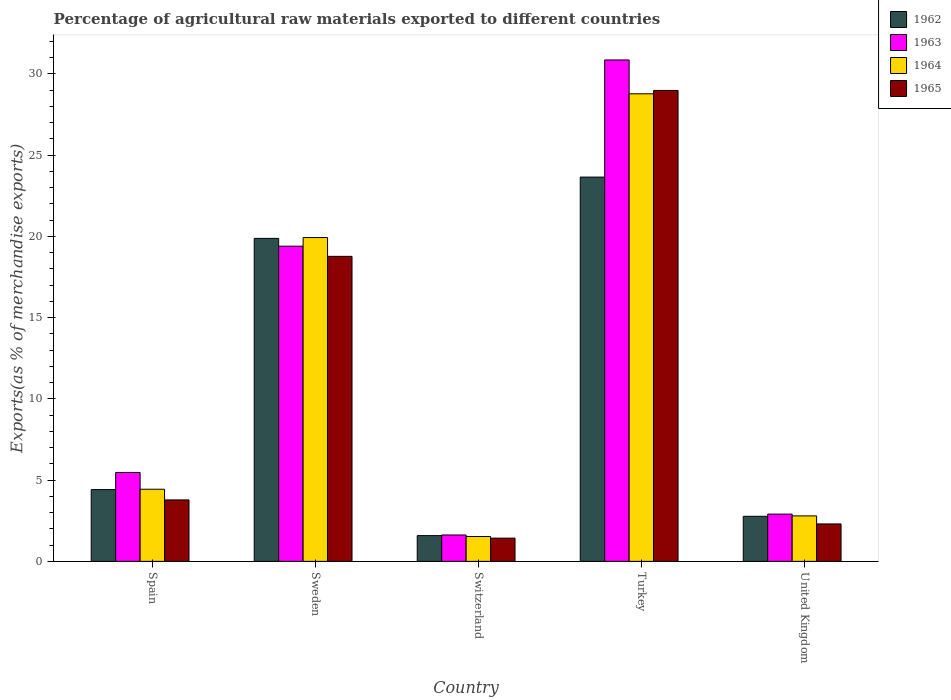How many different coloured bars are there?
Provide a short and direct response. 4. Are the number of bars per tick equal to the number of legend labels?
Provide a succinct answer. Yes. Are the number of bars on each tick of the X-axis equal?
Your answer should be very brief. Yes. How many bars are there on the 3rd tick from the left?
Your answer should be compact. 4. How many bars are there on the 1st tick from the right?
Your response must be concise. 4. In how many cases, is the number of bars for a given country not equal to the number of legend labels?
Your answer should be compact. 0. What is the percentage of exports to different countries in 1965 in United Kingdom?
Your response must be concise. 2.3. Across all countries, what is the maximum percentage of exports to different countries in 1965?
Ensure brevity in your answer.  28.99. Across all countries, what is the minimum percentage of exports to different countries in 1962?
Provide a succinct answer. 1.58. In which country was the percentage of exports to different countries in 1962 maximum?
Provide a short and direct response. Turkey. In which country was the percentage of exports to different countries in 1962 minimum?
Your answer should be very brief. Switzerland. What is the total percentage of exports to different countries in 1963 in the graph?
Provide a short and direct response. 60.27. What is the difference between the percentage of exports to different countries in 1964 in Sweden and that in Turkey?
Your answer should be very brief. -8.85. What is the difference between the percentage of exports to different countries in 1963 in Sweden and the percentage of exports to different countries in 1964 in Turkey?
Offer a very short reply. -9.38. What is the average percentage of exports to different countries in 1965 per country?
Give a very brief answer. 11.06. What is the difference between the percentage of exports to different countries of/in 1964 and percentage of exports to different countries of/in 1963 in Turkey?
Offer a terse response. -2.08. In how many countries, is the percentage of exports to different countries in 1963 greater than 19 %?
Your answer should be compact. 2. What is the ratio of the percentage of exports to different countries in 1965 in Sweden to that in United Kingdom?
Ensure brevity in your answer.  8.15. Is the percentage of exports to different countries in 1964 in Switzerland less than that in Turkey?
Ensure brevity in your answer.  Yes. Is the difference between the percentage of exports to different countries in 1964 in Spain and Sweden greater than the difference between the percentage of exports to different countries in 1963 in Spain and Sweden?
Your answer should be compact. No. What is the difference between the highest and the second highest percentage of exports to different countries in 1964?
Provide a short and direct response. -8.85. What is the difference between the highest and the lowest percentage of exports to different countries in 1963?
Your answer should be very brief. 29.24. What does the 2nd bar from the right in Switzerland represents?
Your answer should be compact. 1964. Is it the case that in every country, the sum of the percentage of exports to different countries in 1963 and percentage of exports to different countries in 1962 is greater than the percentage of exports to different countries in 1965?
Provide a succinct answer. Yes. How many bars are there?
Provide a short and direct response. 20. Are all the bars in the graph horizontal?
Keep it short and to the point. No. Are the values on the major ticks of Y-axis written in scientific E-notation?
Your answer should be very brief. No. Does the graph contain any zero values?
Give a very brief answer. No. Does the graph contain grids?
Your answer should be compact. No. How are the legend labels stacked?
Offer a terse response. Vertical. What is the title of the graph?
Make the answer very short. Percentage of agricultural raw materials exported to different countries. What is the label or title of the Y-axis?
Provide a short and direct response. Exports(as % of merchandise exports). What is the Exports(as % of merchandise exports) of 1962 in Spain?
Keep it short and to the point. 4.42. What is the Exports(as % of merchandise exports) of 1963 in Spain?
Your answer should be compact. 5.47. What is the Exports(as % of merchandise exports) of 1964 in Spain?
Provide a succinct answer. 4.44. What is the Exports(as % of merchandise exports) in 1965 in Spain?
Provide a succinct answer. 3.78. What is the Exports(as % of merchandise exports) of 1962 in Sweden?
Offer a terse response. 19.88. What is the Exports(as % of merchandise exports) in 1963 in Sweden?
Your answer should be compact. 19.4. What is the Exports(as % of merchandise exports) in 1964 in Sweden?
Keep it short and to the point. 19.93. What is the Exports(as % of merchandise exports) in 1965 in Sweden?
Offer a very short reply. 18.78. What is the Exports(as % of merchandise exports) in 1962 in Switzerland?
Your answer should be compact. 1.58. What is the Exports(as % of merchandise exports) of 1963 in Switzerland?
Give a very brief answer. 1.62. What is the Exports(as % of merchandise exports) in 1964 in Switzerland?
Offer a very short reply. 1.53. What is the Exports(as % of merchandise exports) of 1965 in Switzerland?
Provide a short and direct response. 1.43. What is the Exports(as % of merchandise exports) in 1962 in Turkey?
Your answer should be very brief. 23.65. What is the Exports(as % of merchandise exports) of 1963 in Turkey?
Your answer should be very brief. 30.86. What is the Exports(as % of merchandise exports) in 1964 in Turkey?
Your answer should be very brief. 28.78. What is the Exports(as % of merchandise exports) in 1965 in Turkey?
Provide a short and direct response. 28.99. What is the Exports(as % of merchandise exports) in 1962 in United Kingdom?
Your response must be concise. 2.77. What is the Exports(as % of merchandise exports) in 1963 in United Kingdom?
Provide a short and direct response. 2.91. What is the Exports(as % of merchandise exports) of 1964 in United Kingdom?
Offer a very short reply. 2.8. What is the Exports(as % of merchandise exports) in 1965 in United Kingdom?
Ensure brevity in your answer.  2.3. Across all countries, what is the maximum Exports(as % of merchandise exports) in 1962?
Your response must be concise. 23.65. Across all countries, what is the maximum Exports(as % of merchandise exports) in 1963?
Give a very brief answer. 30.86. Across all countries, what is the maximum Exports(as % of merchandise exports) in 1964?
Your response must be concise. 28.78. Across all countries, what is the maximum Exports(as % of merchandise exports) of 1965?
Give a very brief answer. 28.99. Across all countries, what is the minimum Exports(as % of merchandise exports) in 1962?
Your response must be concise. 1.58. Across all countries, what is the minimum Exports(as % of merchandise exports) of 1963?
Your answer should be very brief. 1.62. Across all countries, what is the minimum Exports(as % of merchandise exports) in 1964?
Provide a short and direct response. 1.53. Across all countries, what is the minimum Exports(as % of merchandise exports) in 1965?
Your answer should be compact. 1.43. What is the total Exports(as % of merchandise exports) of 1962 in the graph?
Your answer should be compact. 52.31. What is the total Exports(as % of merchandise exports) in 1963 in the graph?
Give a very brief answer. 60.27. What is the total Exports(as % of merchandise exports) in 1964 in the graph?
Keep it short and to the point. 57.48. What is the total Exports(as % of merchandise exports) of 1965 in the graph?
Your answer should be compact. 55.28. What is the difference between the Exports(as % of merchandise exports) in 1962 in Spain and that in Sweden?
Your response must be concise. -15.46. What is the difference between the Exports(as % of merchandise exports) in 1963 in Spain and that in Sweden?
Your answer should be compact. -13.93. What is the difference between the Exports(as % of merchandise exports) in 1964 in Spain and that in Sweden?
Your response must be concise. -15.49. What is the difference between the Exports(as % of merchandise exports) of 1965 in Spain and that in Sweden?
Your answer should be very brief. -14.99. What is the difference between the Exports(as % of merchandise exports) of 1962 in Spain and that in Switzerland?
Provide a short and direct response. 2.83. What is the difference between the Exports(as % of merchandise exports) in 1963 in Spain and that in Switzerland?
Make the answer very short. 3.85. What is the difference between the Exports(as % of merchandise exports) in 1964 in Spain and that in Switzerland?
Your answer should be very brief. 2.91. What is the difference between the Exports(as % of merchandise exports) of 1965 in Spain and that in Switzerland?
Offer a terse response. 2.35. What is the difference between the Exports(as % of merchandise exports) in 1962 in Spain and that in Turkey?
Provide a succinct answer. -19.24. What is the difference between the Exports(as % of merchandise exports) of 1963 in Spain and that in Turkey?
Offer a very short reply. -25.39. What is the difference between the Exports(as % of merchandise exports) of 1964 in Spain and that in Turkey?
Offer a very short reply. -24.34. What is the difference between the Exports(as % of merchandise exports) of 1965 in Spain and that in Turkey?
Offer a very short reply. -25.21. What is the difference between the Exports(as % of merchandise exports) in 1962 in Spain and that in United Kingdom?
Provide a short and direct response. 1.64. What is the difference between the Exports(as % of merchandise exports) in 1963 in Spain and that in United Kingdom?
Provide a short and direct response. 2.56. What is the difference between the Exports(as % of merchandise exports) in 1964 in Spain and that in United Kingdom?
Make the answer very short. 1.64. What is the difference between the Exports(as % of merchandise exports) in 1965 in Spain and that in United Kingdom?
Offer a terse response. 1.48. What is the difference between the Exports(as % of merchandise exports) of 1962 in Sweden and that in Switzerland?
Make the answer very short. 18.3. What is the difference between the Exports(as % of merchandise exports) in 1963 in Sweden and that in Switzerland?
Ensure brevity in your answer.  17.78. What is the difference between the Exports(as % of merchandise exports) of 1964 in Sweden and that in Switzerland?
Give a very brief answer. 18.4. What is the difference between the Exports(as % of merchandise exports) of 1965 in Sweden and that in Switzerland?
Keep it short and to the point. 17.35. What is the difference between the Exports(as % of merchandise exports) of 1962 in Sweden and that in Turkey?
Your answer should be compact. -3.77. What is the difference between the Exports(as % of merchandise exports) of 1963 in Sweden and that in Turkey?
Provide a short and direct response. -11.46. What is the difference between the Exports(as % of merchandise exports) in 1964 in Sweden and that in Turkey?
Your answer should be compact. -8.85. What is the difference between the Exports(as % of merchandise exports) in 1965 in Sweden and that in Turkey?
Offer a terse response. -10.21. What is the difference between the Exports(as % of merchandise exports) of 1962 in Sweden and that in United Kingdom?
Your response must be concise. 17.11. What is the difference between the Exports(as % of merchandise exports) in 1963 in Sweden and that in United Kingdom?
Provide a short and direct response. 16.49. What is the difference between the Exports(as % of merchandise exports) of 1964 in Sweden and that in United Kingdom?
Provide a short and direct response. 17.13. What is the difference between the Exports(as % of merchandise exports) of 1965 in Sweden and that in United Kingdom?
Your answer should be very brief. 16.47. What is the difference between the Exports(as % of merchandise exports) of 1962 in Switzerland and that in Turkey?
Your answer should be very brief. -22.07. What is the difference between the Exports(as % of merchandise exports) of 1963 in Switzerland and that in Turkey?
Your response must be concise. -29.24. What is the difference between the Exports(as % of merchandise exports) of 1964 in Switzerland and that in Turkey?
Provide a succinct answer. -27.25. What is the difference between the Exports(as % of merchandise exports) of 1965 in Switzerland and that in Turkey?
Keep it short and to the point. -27.56. What is the difference between the Exports(as % of merchandise exports) of 1962 in Switzerland and that in United Kingdom?
Provide a succinct answer. -1.19. What is the difference between the Exports(as % of merchandise exports) in 1963 in Switzerland and that in United Kingdom?
Offer a terse response. -1.28. What is the difference between the Exports(as % of merchandise exports) in 1964 in Switzerland and that in United Kingdom?
Your answer should be compact. -1.27. What is the difference between the Exports(as % of merchandise exports) in 1965 in Switzerland and that in United Kingdom?
Provide a short and direct response. -0.87. What is the difference between the Exports(as % of merchandise exports) of 1962 in Turkey and that in United Kingdom?
Offer a terse response. 20.88. What is the difference between the Exports(as % of merchandise exports) in 1963 in Turkey and that in United Kingdom?
Make the answer very short. 27.96. What is the difference between the Exports(as % of merchandise exports) in 1964 in Turkey and that in United Kingdom?
Offer a terse response. 25.98. What is the difference between the Exports(as % of merchandise exports) in 1965 in Turkey and that in United Kingdom?
Ensure brevity in your answer.  26.68. What is the difference between the Exports(as % of merchandise exports) in 1962 in Spain and the Exports(as % of merchandise exports) in 1963 in Sweden?
Offer a very short reply. -14.98. What is the difference between the Exports(as % of merchandise exports) in 1962 in Spain and the Exports(as % of merchandise exports) in 1964 in Sweden?
Your answer should be compact. -15.51. What is the difference between the Exports(as % of merchandise exports) in 1962 in Spain and the Exports(as % of merchandise exports) in 1965 in Sweden?
Provide a short and direct response. -14.36. What is the difference between the Exports(as % of merchandise exports) in 1963 in Spain and the Exports(as % of merchandise exports) in 1964 in Sweden?
Ensure brevity in your answer.  -14.46. What is the difference between the Exports(as % of merchandise exports) in 1963 in Spain and the Exports(as % of merchandise exports) in 1965 in Sweden?
Give a very brief answer. -13.3. What is the difference between the Exports(as % of merchandise exports) of 1964 in Spain and the Exports(as % of merchandise exports) of 1965 in Sweden?
Make the answer very short. -14.33. What is the difference between the Exports(as % of merchandise exports) of 1962 in Spain and the Exports(as % of merchandise exports) of 1963 in Switzerland?
Make the answer very short. 2.79. What is the difference between the Exports(as % of merchandise exports) in 1962 in Spain and the Exports(as % of merchandise exports) in 1964 in Switzerland?
Make the answer very short. 2.89. What is the difference between the Exports(as % of merchandise exports) in 1962 in Spain and the Exports(as % of merchandise exports) in 1965 in Switzerland?
Ensure brevity in your answer.  2.99. What is the difference between the Exports(as % of merchandise exports) of 1963 in Spain and the Exports(as % of merchandise exports) of 1964 in Switzerland?
Your answer should be compact. 3.94. What is the difference between the Exports(as % of merchandise exports) in 1963 in Spain and the Exports(as % of merchandise exports) in 1965 in Switzerland?
Make the answer very short. 4.04. What is the difference between the Exports(as % of merchandise exports) in 1964 in Spain and the Exports(as % of merchandise exports) in 1965 in Switzerland?
Make the answer very short. 3.01. What is the difference between the Exports(as % of merchandise exports) in 1962 in Spain and the Exports(as % of merchandise exports) in 1963 in Turkey?
Your answer should be compact. -26.45. What is the difference between the Exports(as % of merchandise exports) of 1962 in Spain and the Exports(as % of merchandise exports) of 1964 in Turkey?
Your answer should be compact. -24.36. What is the difference between the Exports(as % of merchandise exports) of 1962 in Spain and the Exports(as % of merchandise exports) of 1965 in Turkey?
Provide a succinct answer. -24.57. What is the difference between the Exports(as % of merchandise exports) in 1963 in Spain and the Exports(as % of merchandise exports) in 1964 in Turkey?
Your response must be concise. -23.31. What is the difference between the Exports(as % of merchandise exports) in 1963 in Spain and the Exports(as % of merchandise exports) in 1965 in Turkey?
Ensure brevity in your answer.  -23.51. What is the difference between the Exports(as % of merchandise exports) in 1964 in Spain and the Exports(as % of merchandise exports) in 1965 in Turkey?
Give a very brief answer. -24.55. What is the difference between the Exports(as % of merchandise exports) in 1962 in Spain and the Exports(as % of merchandise exports) in 1963 in United Kingdom?
Keep it short and to the point. 1.51. What is the difference between the Exports(as % of merchandise exports) of 1962 in Spain and the Exports(as % of merchandise exports) of 1964 in United Kingdom?
Your response must be concise. 1.62. What is the difference between the Exports(as % of merchandise exports) in 1962 in Spain and the Exports(as % of merchandise exports) in 1965 in United Kingdom?
Provide a short and direct response. 2.11. What is the difference between the Exports(as % of merchandise exports) in 1963 in Spain and the Exports(as % of merchandise exports) in 1964 in United Kingdom?
Your response must be concise. 2.68. What is the difference between the Exports(as % of merchandise exports) in 1963 in Spain and the Exports(as % of merchandise exports) in 1965 in United Kingdom?
Offer a terse response. 3.17. What is the difference between the Exports(as % of merchandise exports) of 1964 in Spain and the Exports(as % of merchandise exports) of 1965 in United Kingdom?
Keep it short and to the point. 2.14. What is the difference between the Exports(as % of merchandise exports) of 1962 in Sweden and the Exports(as % of merchandise exports) of 1963 in Switzerland?
Ensure brevity in your answer.  18.26. What is the difference between the Exports(as % of merchandise exports) in 1962 in Sweden and the Exports(as % of merchandise exports) in 1964 in Switzerland?
Ensure brevity in your answer.  18.35. What is the difference between the Exports(as % of merchandise exports) of 1962 in Sweden and the Exports(as % of merchandise exports) of 1965 in Switzerland?
Give a very brief answer. 18.45. What is the difference between the Exports(as % of merchandise exports) in 1963 in Sweden and the Exports(as % of merchandise exports) in 1964 in Switzerland?
Your answer should be compact. 17.87. What is the difference between the Exports(as % of merchandise exports) in 1963 in Sweden and the Exports(as % of merchandise exports) in 1965 in Switzerland?
Ensure brevity in your answer.  17.97. What is the difference between the Exports(as % of merchandise exports) in 1964 in Sweden and the Exports(as % of merchandise exports) in 1965 in Switzerland?
Offer a very short reply. 18.5. What is the difference between the Exports(as % of merchandise exports) of 1962 in Sweden and the Exports(as % of merchandise exports) of 1963 in Turkey?
Provide a succinct answer. -10.98. What is the difference between the Exports(as % of merchandise exports) in 1962 in Sweden and the Exports(as % of merchandise exports) in 1964 in Turkey?
Your answer should be compact. -8.9. What is the difference between the Exports(as % of merchandise exports) in 1962 in Sweden and the Exports(as % of merchandise exports) in 1965 in Turkey?
Give a very brief answer. -9.11. What is the difference between the Exports(as % of merchandise exports) of 1963 in Sweden and the Exports(as % of merchandise exports) of 1964 in Turkey?
Your answer should be compact. -9.38. What is the difference between the Exports(as % of merchandise exports) in 1963 in Sweden and the Exports(as % of merchandise exports) in 1965 in Turkey?
Your answer should be very brief. -9.59. What is the difference between the Exports(as % of merchandise exports) in 1964 in Sweden and the Exports(as % of merchandise exports) in 1965 in Turkey?
Offer a very short reply. -9.06. What is the difference between the Exports(as % of merchandise exports) of 1962 in Sweden and the Exports(as % of merchandise exports) of 1963 in United Kingdom?
Offer a terse response. 16.97. What is the difference between the Exports(as % of merchandise exports) in 1962 in Sweden and the Exports(as % of merchandise exports) in 1964 in United Kingdom?
Give a very brief answer. 17.08. What is the difference between the Exports(as % of merchandise exports) in 1962 in Sweden and the Exports(as % of merchandise exports) in 1965 in United Kingdom?
Ensure brevity in your answer.  17.58. What is the difference between the Exports(as % of merchandise exports) of 1963 in Sweden and the Exports(as % of merchandise exports) of 1964 in United Kingdom?
Offer a terse response. 16.6. What is the difference between the Exports(as % of merchandise exports) of 1963 in Sweden and the Exports(as % of merchandise exports) of 1965 in United Kingdom?
Your answer should be compact. 17.1. What is the difference between the Exports(as % of merchandise exports) of 1964 in Sweden and the Exports(as % of merchandise exports) of 1965 in United Kingdom?
Offer a terse response. 17.63. What is the difference between the Exports(as % of merchandise exports) of 1962 in Switzerland and the Exports(as % of merchandise exports) of 1963 in Turkey?
Your answer should be compact. -29.28. What is the difference between the Exports(as % of merchandise exports) in 1962 in Switzerland and the Exports(as % of merchandise exports) in 1964 in Turkey?
Provide a succinct answer. -27.2. What is the difference between the Exports(as % of merchandise exports) in 1962 in Switzerland and the Exports(as % of merchandise exports) in 1965 in Turkey?
Make the answer very short. -27.4. What is the difference between the Exports(as % of merchandise exports) of 1963 in Switzerland and the Exports(as % of merchandise exports) of 1964 in Turkey?
Your answer should be compact. -27.16. What is the difference between the Exports(as % of merchandise exports) in 1963 in Switzerland and the Exports(as % of merchandise exports) in 1965 in Turkey?
Provide a succinct answer. -27.36. What is the difference between the Exports(as % of merchandise exports) of 1964 in Switzerland and the Exports(as % of merchandise exports) of 1965 in Turkey?
Provide a succinct answer. -27.46. What is the difference between the Exports(as % of merchandise exports) of 1962 in Switzerland and the Exports(as % of merchandise exports) of 1963 in United Kingdom?
Provide a short and direct response. -1.32. What is the difference between the Exports(as % of merchandise exports) in 1962 in Switzerland and the Exports(as % of merchandise exports) in 1964 in United Kingdom?
Your response must be concise. -1.21. What is the difference between the Exports(as % of merchandise exports) in 1962 in Switzerland and the Exports(as % of merchandise exports) in 1965 in United Kingdom?
Offer a very short reply. -0.72. What is the difference between the Exports(as % of merchandise exports) of 1963 in Switzerland and the Exports(as % of merchandise exports) of 1964 in United Kingdom?
Ensure brevity in your answer.  -1.17. What is the difference between the Exports(as % of merchandise exports) of 1963 in Switzerland and the Exports(as % of merchandise exports) of 1965 in United Kingdom?
Make the answer very short. -0.68. What is the difference between the Exports(as % of merchandise exports) in 1964 in Switzerland and the Exports(as % of merchandise exports) in 1965 in United Kingdom?
Your answer should be very brief. -0.78. What is the difference between the Exports(as % of merchandise exports) in 1962 in Turkey and the Exports(as % of merchandise exports) in 1963 in United Kingdom?
Provide a succinct answer. 20.75. What is the difference between the Exports(as % of merchandise exports) of 1962 in Turkey and the Exports(as % of merchandise exports) of 1964 in United Kingdom?
Give a very brief answer. 20.86. What is the difference between the Exports(as % of merchandise exports) of 1962 in Turkey and the Exports(as % of merchandise exports) of 1965 in United Kingdom?
Keep it short and to the point. 21.35. What is the difference between the Exports(as % of merchandise exports) of 1963 in Turkey and the Exports(as % of merchandise exports) of 1964 in United Kingdom?
Offer a terse response. 28.07. What is the difference between the Exports(as % of merchandise exports) in 1963 in Turkey and the Exports(as % of merchandise exports) in 1965 in United Kingdom?
Offer a terse response. 28.56. What is the difference between the Exports(as % of merchandise exports) in 1964 in Turkey and the Exports(as % of merchandise exports) in 1965 in United Kingdom?
Provide a short and direct response. 26.48. What is the average Exports(as % of merchandise exports) in 1962 per country?
Offer a terse response. 10.46. What is the average Exports(as % of merchandise exports) in 1963 per country?
Offer a terse response. 12.05. What is the average Exports(as % of merchandise exports) of 1964 per country?
Your answer should be compact. 11.5. What is the average Exports(as % of merchandise exports) in 1965 per country?
Keep it short and to the point. 11.06. What is the difference between the Exports(as % of merchandise exports) of 1962 and Exports(as % of merchandise exports) of 1963 in Spain?
Give a very brief answer. -1.06. What is the difference between the Exports(as % of merchandise exports) of 1962 and Exports(as % of merchandise exports) of 1964 in Spain?
Provide a short and direct response. -0.02. What is the difference between the Exports(as % of merchandise exports) of 1962 and Exports(as % of merchandise exports) of 1965 in Spain?
Offer a terse response. 0.64. What is the difference between the Exports(as % of merchandise exports) of 1963 and Exports(as % of merchandise exports) of 1964 in Spain?
Keep it short and to the point. 1.03. What is the difference between the Exports(as % of merchandise exports) of 1963 and Exports(as % of merchandise exports) of 1965 in Spain?
Your answer should be very brief. 1.69. What is the difference between the Exports(as % of merchandise exports) of 1964 and Exports(as % of merchandise exports) of 1965 in Spain?
Keep it short and to the point. 0.66. What is the difference between the Exports(as % of merchandise exports) in 1962 and Exports(as % of merchandise exports) in 1963 in Sweden?
Make the answer very short. 0.48. What is the difference between the Exports(as % of merchandise exports) of 1962 and Exports(as % of merchandise exports) of 1964 in Sweden?
Keep it short and to the point. -0.05. What is the difference between the Exports(as % of merchandise exports) of 1962 and Exports(as % of merchandise exports) of 1965 in Sweden?
Make the answer very short. 1.1. What is the difference between the Exports(as % of merchandise exports) in 1963 and Exports(as % of merchandise exports) in 1964 in Sweden?
Provide a succinct answer. -0.53. What is the difference between the Exports(as % of merchandise exports) in 1963 and Exports(as % of merchandise exports) in 1965 in Sweden?
Give a very brief answer. 0.63. What is the difference between the Exports(as % of merchandise exports) of 1964 and Exports(as % of merchandise exports) of 1965 in Sweden?
Provide a short and direct response. 1.16. What is the difference between the Exports(as % of merchandise exports) of 1962 and Exports(as % of merchandise exports) of 1963 in Switzerland?
Make the answer very short. -0.04. What is the difference between the Exports(as % of merchandise exports) of 1962 and Exports(as % of merchandise exports) of 1964 in Switzerland?
Provide a succinct answer. 0.06. What is the difference between the Exports(as % of merchandise exports) of 1962 and Exports(as % of merchandise exports) of 1965 in Switzerland?
Offer a terse response. 0.15. What is the difference between the Exports(as % of merchandise exports) in 1963 and Exports(as % of merchandise exports) in 1964 in Switzerland?
Your answer should be very brief. 0.1. What is the difference between the Exports(as % of merchandise exports) in 1963 and Exports(as % of merchandise exports) in 1965 in Switzerland?
Offer a terse response. 0.19. What is the difference between the Exports(as % of merchandise exports) in 1964 and Exports(as % of merchandise exports) in 1965 in Switzerland?
Make the answer very short. 0.1. What is the difference between the Exports(as % of merchandise exports) in 1962 and Exports(as % of merchandise exports) in 1963 in Turkey?
Provide a succinct answer. -7.21. What is the difference between the Exports(as % of merchandise exports) in 1962 and Exports(as % of merchandise exports) in 1964 in Turkey?
Offer a very short reply. -5.13. What is the difference between the Exports(as % of merchandise exports) in 1962 and Exports(as % of merchandise exports) in 1965 in Turkey?
Make the answer very short. -5.33. What is the difference between the Exports(as % of merchandise exports) of 1963 and Exports(as % of merchandise exports) of 1964 in Turkey?
Provide a succinct answer. 2.08. What is the difference between the Exports(as % of merchandise exports) in 1963 and Exports(as % of merchandise exports) in 1965 in Turkey?
Give a very brief answer. 1.88. What is the difference between the Exports(as % of merchandise exports) in 1964 and Exports(as % of merchandise exports) in 1965 in Turkey?
Your answer should be very brief. -0.21. What is the difference between the Exports(as % of merchandise exports) in 1962 and Exports(as % of merchandise exports) in 1963 in United Kingdom?
Ensure brevity in your answer.  -0.13. What is the difference between the Exports(as % of merchandise exports) in 1962 and Exports(as % of merchandise exports) in 1964 in United Kingdom?
Your answer should be very brief. -0.02. What is the difference between the Exports(as % of merchandise exports) of 1962 and Exports(as % of merchandise exports) of 1965 in United Kingdom?
Offer a very short reply. 0.47. What is the difference between the Exports(as % of merchandise exports) of 1963 and Exports(as % of merchandise exports) of 1964 in United Kingdom?
Offer a very short reply. 0.11. What is the difference between the Exports(as % of merchandise exports) in 1963 and Exports(as % of merchandise exports) in 1965 in United Kingdom?
Ensure brevity in your answer.  0.6. What is the difference between the Exports(as % of merchandise exports) of 1964 and Exports(as % of merchandise exports) of 1965 in United Kingdom?
Your answer should be very brief. 0.49. What is the ratio of the Exports(as % of merchandise exports) in 1962 in Spain to that in Sweden?
Give a very brief answer. 0.22. What is the ratio of the Exports(as % of merchandise exports) in 1963 in Spain to that in Sweden?
Your response must be concise. 0.28. What is the ratio of the Exports(as % of merchandise exports) of 1964 in Spain to that in Sweden?
Keep it short and to the point. 0.22. What is the ratio of the Exports(as % of merchandise exports) of 1965 in Spain to that in Sweden?
Provide a succinct answer. 0.2. What is the ratio of the Exports(as % of merchandise exports) of 1962 in Spain to that in Switzerland?
Make the answer very short. 2.79. What is the ratio of the Exports(as % of merchandise exports) in 1963 in Spain to that in Switzerland?
Keep it short and to the point. 3.37. What is the ratio of the Exports(as % of merchandise exports) in 1964 in Spain to that in Switzerland?
Offer a terse response. 2.9. What is the ratio of the Exports(as % of merchandise exports) in 1965 in Spain to that in Switzerland?
Ensure brevity in your answer.  2.65. What is the ratio of the Exports(as % of merchandise exports) of 1962 in Spain to that in Turkey?
Make the answer very short. 0.19. What is the ratio of the Exports(as % of merchandise exports) of 1963 in Spain to that in Turkey?
Your answer should be very brief. 0.18. What is the ratio of the Exports(as % of merchandise exports) of 1964 in Spain to that in Turkey?
Offer a very short reply. 0.15. What is the ratio of the Exports(as % of merchandise exports) in 1965 in Spain to that in Turkey?
Provide a short and direct response. 0.13. What is the ratio of the Exports(as % of merchandise exports) in 1962 in Spain to that in United Kingdom?
Your answer should be compact. 1.59. What is the ratio of the Exports(as % of merchandise exports) of 1963 in Spain to that in United Kingdom?
Ensure brevity in your answer.  1.88. What is the ratio of the Exports(as % of merchandise exports) of 1964 in Spain to that in United Kingdom?
Your response must be concise. 1.59. What is the ratio of the Exports(as % of merchandise exports) in 1965 in Spain to that in United Kingdom?
Give a very brief answer. 1.64. What is the ratio of the Exports(as % of merchandise exports) in 1962 in Sweden to that in Switzerland?
Ensure brevity in your answer.  12.55. What is the ratio of the Exports(as % of merchandise exports) in 1963 in Sweden to that in Switzerland?
Your answer should be very brief. 11.95. What is the ratio of the Exports(as % of merchandise exports) in 1964 in Sweden to that in Switzerland?
Provide a succinct answer. 13.04. What is the ratio of the Exports(as % of merchandise exports) in 1965 in Sweden to that in Switzerland?
Your answer should be compact. 13.13. What is the ratio of the Exports(as % of merchandise exports) in 1962 in Sweden to that in Turkey?
Your answer should be compact. 0.84. What is the ratio of the Exports(as % of merchandise exports) in 1963 in Sweden to that in Turkey?
Offer a terse response. 0.63. What is the ratio of the Exports(as % of merchandise exports) of 1964 in Sweden to that in Turkey?
Make the answer very short. 0.69. What is the ratio of the Exports(as % of merchandise exports) of 1965 in Sweden to that in Turkey?
Ensure brevity in your answer.  0.65. What is the ratio of the Exports(as % of merchandise exports) in 1962 in Sweden to that in United Kingdom?
Your answer should be very brief. 7.17. What is the ratio of the Exports(as % of merchandise exports) of 1963 in Sweden to that in United Kingdom?
Make the answer very short. 6.67. What is the ratio of the Exports(as % of merchandise exports) in 1964 in Sweden to that in United Kingdom?
Keep it short and to the point. 7.12. What is the ratio of the Exports(as % of merchandise exports) of 1965 in Sweden to that in United Kingdom?
Ensure brevity in your answer.  8.15. What is the ratio of the Exports(as % of merchandise exports) in 1962 in Switzerland to that in Turkey?
Make the answer very short. 0.07. What is the ratio of the Exports(as % of merchandise exports) of 1963 in Switzerland to that in Turkey?
Make the answer very short. 0.05. What is the ratio of the Exports(as % of merchandise exports) of 1964 in Switzerland to that in Turkey?
Your response must be concise. 0.05. What is the ratio of the Exports(as % of merchandise exports) of 1965 in Switzerland to that in Turkey?
Your answer should be compact. 0.05. What is the ratio of the Exports(as % of merchandise exports) of 1962 in Switzerland to that in United Kingdom?
Ensure brevity in your answer.  0.57. What is the ratio of the Exports(as % of merchandise exports) in 1963 in Switzerland to that in United Kingdom?
Your answer should be very brief. 0.56. What is the ratio of the Exports(as % of merchandise exports) of 1964 in Switzerland to that in United Kingdom?
Give a very brief answer. 0.55. What is the ratio of the Exports(as % of merchandise exports) of 1965 in Switzerland to that in United Kingdom?
Offer a terse response. 0.62. What is the ratio of the Exports(as % of merchandise exports) in 1962 in Turkey to that in United Kingdom?
Your response must be concise. 8.53. What is the ratio of the Exports(as % of merchandise exports) of 1963 in Turkey to that in United Kingdom?
Give a very brief answer. 10.61. What is the ratio of the Exports(as % of merchandise exports) of 1964 in Turkey to that in United Kingdom?
Ensure brevity in your answer.  10.28. What is the ratio of the Exports(as % of merchandise exports) in 1965 in Turkey to that in United Kingdom?
Your response must be concise. 12.58. What is the difference between the highest and the second highest Exports(as % of merchandise exports) in 1962?
Provide a short and direct response. 3.77. What is the difference between the highest and the second highest Exports(as % of merchandise exports) in 1963?
Provide a short and direct response. 11.46. What is the difference between the highest and the second highest Exports(as % of merchandise exports) of 1964?
Provide a short and direct response. 8.85. What is the difference between the highest and the second highest Exports(as % of merchandise exports) of 1965?
Provide a succinct answer. 10.21. What is the difference between the highest and the lowest Exports(as % of merchandise exports) in 1962?
Offer a terse response. 22.07. What is the difference between the highest and the lowest Exports(as % of merchandise exports) of 1963?
Give a very brief answer. 29.24. What is the difference between the highest and the lowest Exports(as % of merchandise exports) of 1964?
Keep it short and to the point. 27.25. What is the difference between the highest and the lowest Exports(as % of merchandise exports) in 1965?
Provide a succinct answer. 27.56. 